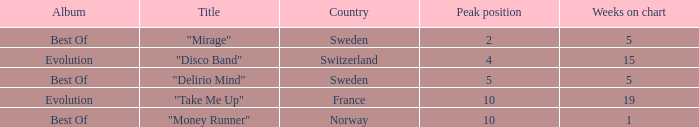Could you help me parse every detail presented in this table? {'header': ['Album', 'Title', 'Country', 'Peak position', 'Weeks on chart'], 'rows': [['Best Of', '"Mirage"', 'Sweden', '2', '5'], ['Evolution', '"Disco Band"', 'Switzerland', '4', '15'], ['Best Of', '"Delirio Mind"', 'Sweden', '5', '5'], ['Evolution', '"Take Me Up"', 'France', '10', '19'], ['Best Of', '"Money Runner"', 'Norway', '10', '1']]} What is the country with the album best of and weeks on chart is less than 5? Norway. 